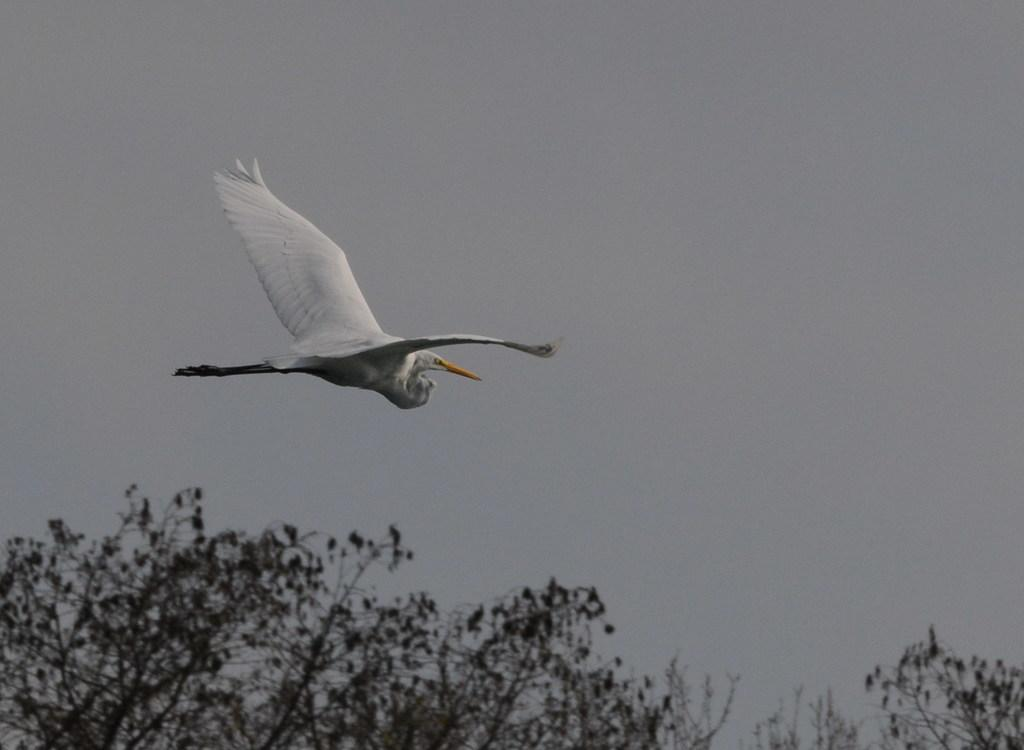What type of animal can be seen in the image? There is a white color bird in the image. What is the bird doing in the image? The bird is flying in the sky. What can be seen in the background of the image? There are trees visible in the image. What type of control system is being used by the bird to fly in the image? Birds do not use control systems to fly; they have natural abilities to fly using their wings. 